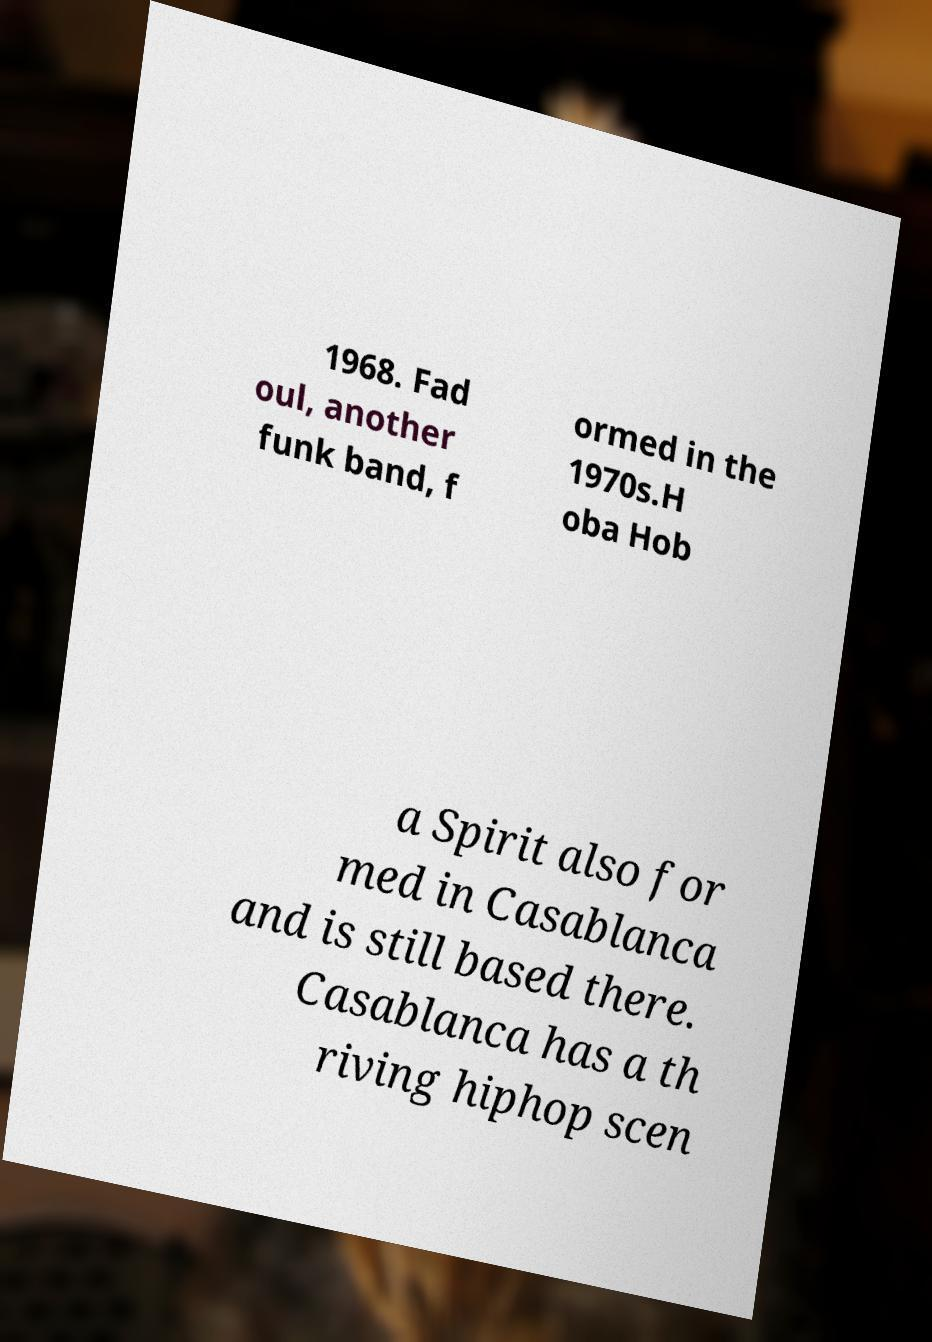For documentation purposes, I need the text within this image transcribed. Could you provide that? 1968. Fad oul, another funk band, f ormed in the 1970s.H oba Hob a Spirit also for med in Casablanca and is still based there. Casablanca has a th riving hiphop scen 